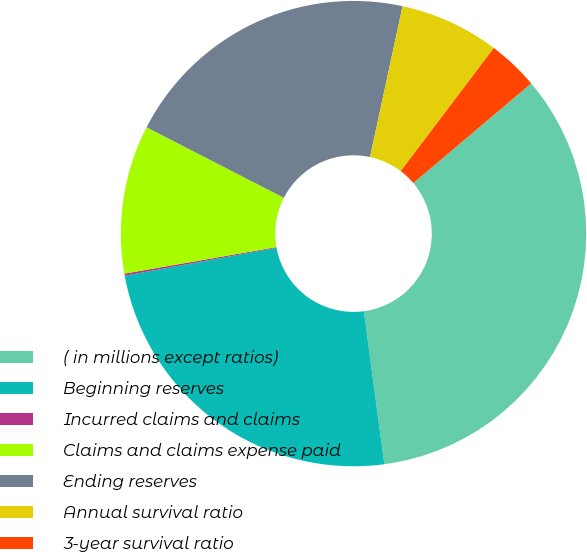<chart> <loc_0><loc_0><loc_500><loc_500><pie_chart><fcel>( in millions except ratios)<fcel>Beginning reserves<fcel>Incurred claims and claims<fcel>Claims and claims expense paid<fcel>Ending reserves<fcel>Annual survival ratio<fcel>3-year survival ratio<nl><fcel>34.06%<fcel>24.22%<fcel>0.14%<fcel>10.31%<fcel>20.83%<fcel>6.92%<fcel>3.53%<nl></chart> 